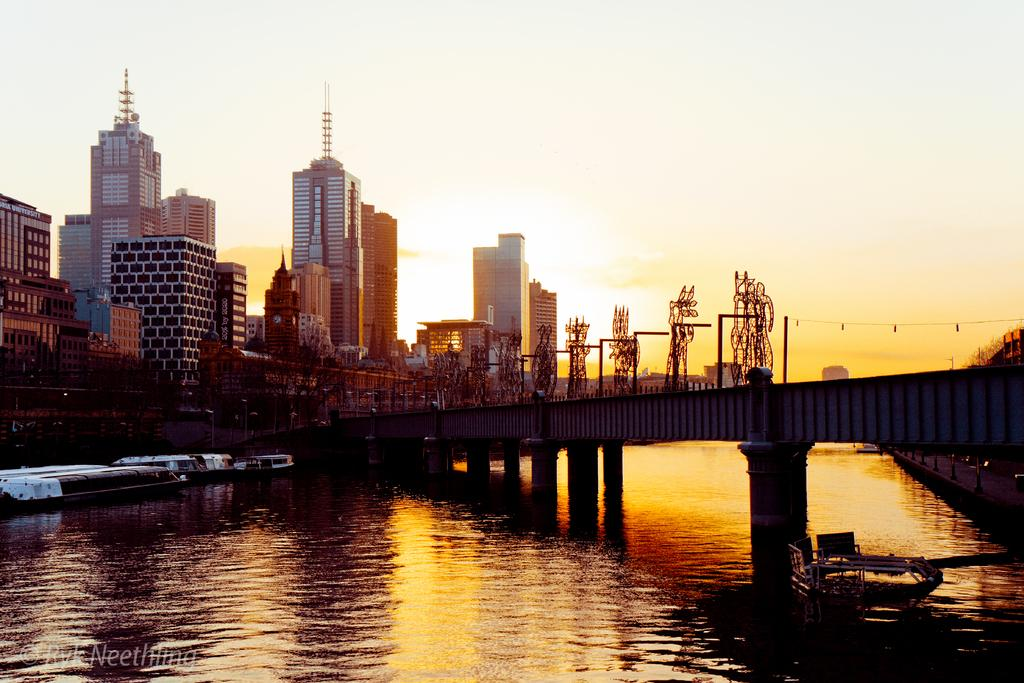What is in the water in the image? There are boats in the water in the image. What structure can be seen crossing over the water? There is a bridge in the image. What type of man-made structures are visible in the image? There are buildings visible in the image. What type of crime is being committed on the bridge in the image? There is no crime being committed in the image; it only shows boats, a bridge, and buildings. What color is the silver expansion visible in the image? There is no silver expansion present in the image. 